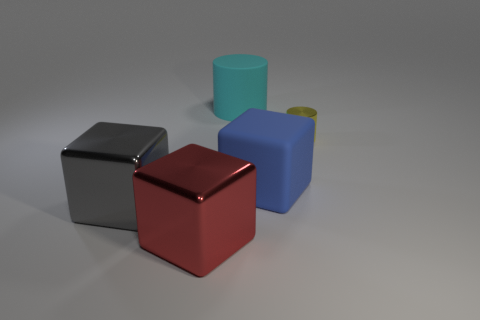Is there any other thing that has the same size as the metal cylinder?
Your answer should be very brief. No. What color is the rubber thing that is the same size as the cyan rubber cylinder?
Provide a short and direct response. Blue. There is a metallic thing that is on the right side of the matte thing that is behind the large object that is to the right of the large cyan matte cylinder; what is its shape?
Give a very brief answer. Cylinder. There is a cylinder that is to the right of the big cyan matte thing; how many metal cylinders are in front of it?
Offer a terse response. 0. There is a large rubber object that is behind the shiny cylinder; does it have the same shape as the metal thing that is right of the red thing?
Your answer should be very brief. Yes. How many big matte things are behind the big matte cylinder?
Make the answer very short. 0. Is the cube that is left of the large red metallic cube made of the same material as the large cyan cylinder?
Keep it short and to the point. No. The large thing that is the same shape as the small yellow shiny thing is what color?
Your answer should be compact. Cyan. The cyan rubber thing has what shape?
Your answer should be very brief. Cylinder. How many things are either big brown objects or large shiny things?
Your answer should be very brief. 2. 